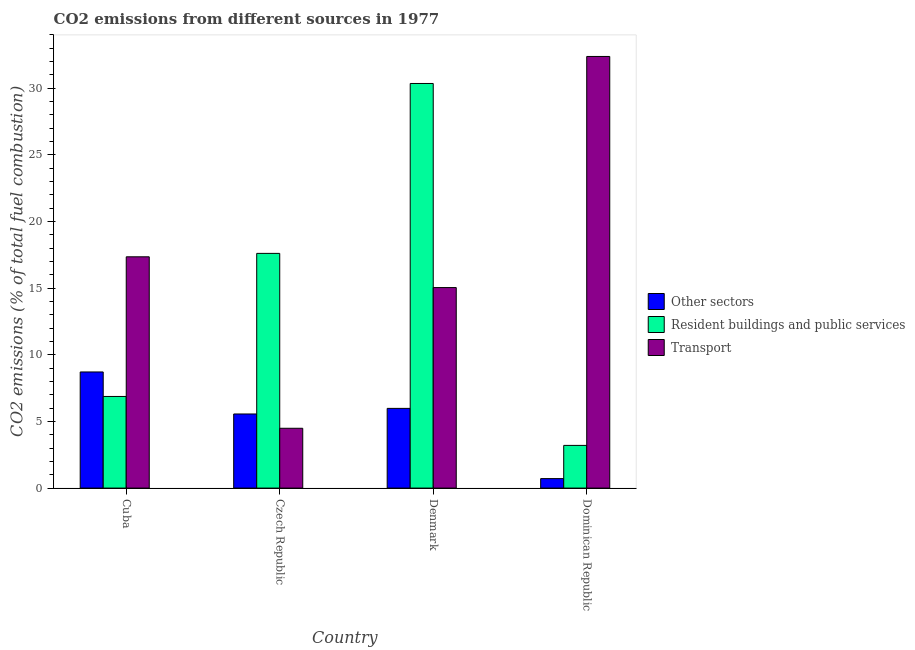How many different coloured bars are there?
Your response must be concise. 3. Are the number of bars per tick equal to the number of legend labels?
Offer a terse response. Yes. Are the number of bars on each tick of the X-axis equal?
Give a very brief answer. Yes. In how many cases, is the number of bars for a given country not equal to the number of legend labels?
Provide a short and direct response. 0. What is the percentage of co2 emissions from other sectors in Cuba?
Keep it short and to the point. 8.71. Across all countries, what is the maximum percentage of co2 emissions from resident buildings and public services?
Your answer should be compact. 30.36. Across all countries, what is the minimum percentage of co2 emissions from resident buildings and public services?
Offer a very short reply. 3.2. In which country was the percentage of co2 emissions from resident buildings and public services minimum?
Offer a very short reply. Dominican Republic. What is the total percentage of co2 emissions from other sectors in the graph?
Your response must be concise. 20.97. What is the difference between the percentage of co2 emissions from other sectors in Czech Republic and that in Dominican Republic?
Provide a succinct answer. 4.85. What is the difference between the percentage of co2 emissions from other sectors in Czech Republic and the percentage of co2 emissions from resident buildings and public services in Dominican Republic?
Offer a terse response. 2.36. What is the average percentage of co2 emissions from resident buildings and public services per country?
Your response must be concise. 14.51. What is the difference between the percentage of co2 emissions from resident buildings and public services and percentage of co2 emissions from transport in Cuba?
Offer a very short reply. -10.48. What is the ratio of the percentage of co2 emissions from transport in Cuba to that in Czech Republic?
Offer a very short reply. 3.87. Is the percentage of co2 emissions from transport in Czech Republic less than that in Dominican Republic?
Provide a succinct answer. Yes. What is the difference between the highest and the second highest percentage of co2 emissions from resident buildings and public services?
Offer a terse response. 12.75. What is the difference between the highest and the lowest percentage of co2 emissions from transport?
Offer a terse response. 27.9. Is the sum of the percentage of co2 emissions from other sectors in Czech Republic and Denmark greater than the maximum percentage of co2 emissions from resident buildings and public services across all countries?
Give a very brief answer. No. What does the 2nd bar from the left in Czech Republic represents?
Make the answer very short. Resident buildings and public services. What does the 3rd bar from the right in Denmark represents?
Give a very brief answer. Other sectors. Are all the bars in the graph horizontal?
Your answer should be very brief. No. Does the graph contain any zero values?
Keep it short and to the point. No. Does the graph contain grids?
Ensure brevity in your answer.  No. Where does the legend appear in the graph?
Your answer should be compact. Center right. How many legend labels are there?
Your response must be concise. 3. How are the legend labels stacked?
Your answer should be compact. Vertical. What is the title of the graph?
Give a very brief answer. CO2 emissions from different sources in 1977. What is the label or title of the X-axis?
Your response must be concise. Country. What is the label or title of the Y-axis?
Offer a terse response. CO2 emissions (% of total fuel combustion). What is the CO2 emissions (% of total fuel combustion) of Other sectors in Cuba?
Offer a very short reply. 8.71. What is the CO2 emissions (% of total fuel combustion) in Resident buildings and public services in Cuba?
Offer a very short reply. 6.88. What is the CO2 emissions (% of total fuel combustion) in Transport in Cuba?
Provide a short and direct response. 17.35. What is the CO2 emissions (% of total fuel combustion) of Other sectors in Czech Republic?
Provide a succinct answer. 5.56. What is the CO2 emissions (% of total fuel combustion) in Resident buildings and public services in Czech Republic?
Your answer should be very brief. 17.61. What is the CO2 emissions (% of total fuel combustion) in Transport in Czech Republic?
Make the answer very short. 4.49. What is the CO2 emissions (% of total fuel combustion) in Other sectors in Denmark?
Give a very brief answer. 5.98. What is the CO2 emissions (% of total fuel combustion) in Resident buildings and public services in Denmark?
Provide a short and direct response. 30.36. What is the CO2 emissions (% of total fuel combustion) in Transport in Denmark?
Ensure brevity in your answer.  15.04. What is the CO2 emissions (% of total fuel combustion) in Other sectors in Dominican Republic?
Offer a terse response. 0.71. What is the CO2 emissions (% of total fuel combustion) in Resident buildings and public services in Dominican Republic?
Provide a short and direct response. 3.2. What is the CO2 emissions (% of total fuel combustion) of Transport in Dominican Republic?
Give a very brief answer. 32.38. Across all countries, what is the maximum CO2 emissions (% of total fuel combustion) in Other sectors?
Provide a short and direct response. 8.71. Across all countries, what is the maximum CO2 emissions (% of total fuel combustion) of Resident buildings and public services?
Give a very brief answer. 30.36. Across all countries, what is the maximum CO2 emissions (% of total fuel combustion) of Transport?
Your response must be concise. 32.38. Across all countries, what is the minimum CO2 emissions (% of total fuel combustion) of Other sectors?
Offer a terse response. 0.71. Across all countries, what is the minimum CO2 emissions (% of total fuel combustion) of Resident buildings and public services?
Offer a terse response. 3.2. Across all countries, what is the minimum CO2 emissions (% of total fuel combustion) in Transport?
Offer a terse response. 4.49. What is the total CO2 emissions (% of total fuel combustion) of Other sectors in the graph?
Make the answer very short. 20.97. What is the total CO2 emissions (% of total fuel combustion) of Resident buildings and public services in the graph?
Offer a very short reply. 58.04. What is the total CO2 emissions (% of total fuel combustion) of Transport in the graph?
Your answer should be very brief. 69.27. What is the difference between the CO2 emissions (% of total fuel combustion) of Other sectors in Cuba and that in Czech Republic?
Make the answer very short. 3.15. What is the difference between the CO2 emissions (% of total fuel combustion) of Resident buildings and public services in Cuba and that in Czech Republic?
Give a very brief answer. -10.73. What is the difference between the CO2 emissions (% of total fuel combustion) of Transport in Cuba and that in Czech Republic?
Make the answer very short. 12.87. What is the difference between the CO2 emissions (% of total fuel combustion) in Other sectors in Cuba and that in Denmark?
Make the answer very short. 2.73. What is the difference between the CO2 emissions (% of total fuel combustion) in Resident buildings and public services in Cuba and that in Denmark?
Your answer should be very brief. -23.48. What is the difference between the CO2 emissions (% of total fuel combustion) in Transport in Cuba and that in Denmark?
Your answer should be very brief. 2.31. What is the difference between the CO2 emissions (% of total fuel combustion) of Other sectors in Cuba and that in Dominican Republic?
Give a very brief answer. 8. What is the difference between the CO2 emissions (% of total fuel combustion) in Resident buildings and public services in Cuba and that in Dominican Republic?
Make the answer very short. 3.67. What is the difference between the CO2 emissions (% of total fuel combustion) in Transport in Cuba and that in Dominican Republic?
Provide a succinct answer. -15.03. What is the difference between the CO2 emissions (% of total fuel combustion) of Other sectors in Czech Republic and that in Denmark?
Give a very brief answer. -0.42. What is the difference between the CO2 emissions (% of total fuel combustion) in Resident buildings and public services in Czech Republic and that in Denmark?
Give a very brief answer. -12.75. What is the difference between the CO2 emissions (% of total fuel combustion) in Transport in Czech Republic and that in Denmark?
Give a very brief answer. -10.56. What is the difference between the CO2 emissions (% of total fuel combustion) in Other sectors in Czech Republic and that in Dominican Republic?
Provide a short and direct response. 4.85. What is the difference between the CO2 emissions (% of total fuel combustion) in Resident buildings and public services in Czech Republic and that in Dominican Republic?
Ensure brevity in your answer.  14.41. What is the difference between the CO2 emissions (% of total fuel combustion) in Transport in Czech Republic and that in Dominican Republic?
Make the answer very short. -27.9. What is the difference between the CO2 emissions (% of total fuel combustion) of Other sectors in Denmark and that in Dominican Republic?
Make the answer very short. 5.27. What is the difference between the CO2 emissions (% of total fuel combustion) of Resident buildings and public services in Denmark and that in Dominican Republic?
Provide a succinct answer. 27.15. What is the difference between the CO2 emissions (% of total fuel combustion) of Transport in Denmark and that in Dominican Republic?
Ensure brevity in your answer.  -17.34. What is the difference between the CO2 emissions (% of total fuel combustion) in Other sectors in Cuba and the CO2 emissions (% of total fuel combustion) in Resident buildings and public services in Czech Republic?
Make the answer very short. -8.9. What is the difference between the CO2 emissions (% of total fuel combustion) in Other sectors in Cuba and the CO2 emissions (% of total fuel combustion) in Transport in Czech Republic?
Provide a short and direct response. 4.23. What is the difference between the CO2 emissions (% of total fuel combustion) in Resident buildings and public services in Cuba and the CO2 emissions (% of total fuel combustion) in Transport in Czech Republic?
Ensure brevity in your answer.  2.39. What is the difference between the CO2 emissions (% of total fuel combustion) of Other sectors in Cuba and the CO2 emissions (% of total fuel combustion) of Resident buildings and public services in Denmark?
Provide a succinct answer. -21.64. What is the difference between the CO2 emissions (% of total fuel combustion) of Other sectors in Cuba and the CO2 emissions (% of total fuel combustion) of Transport in Denmark?
Your answer should be compact. -6.33. What is the difference between the CO2 emissions (% of total fuel combustion) in Resident buildings and public services in Cuba and the CO2 emissions (% of total fuel combustion) in Transport in Denmark?
Give a very brief answer. -8.17. What is the difference between the CO2 emissions (% of total fuel combustion) of Other sectors in Cuba and the CO2 emissions (% of total fuel combustion) of Resident buildings and public services in Dominican Republic?
Make the answer very short. 5.51. What is the difference between the CO2 emissions (% of total fuel combustion) in Other sectors in Cuba and the CO2 emissions (% of total fuel combustion) in Transport in Dominican Republic?
Your answer should be very brief. -23.67. What is the difference between the CO2 emissions (% of total fuel combustion) of Resident buildings and public services in Cuba and the CO2 emissions (% of total fuel combustion) of Transport in Dominican Republic?
Offer a very short reply. -25.51. What is the difference between the CO2 emissions (% of total fuel combustion) in Other sectors in Czech Republic and the CO2 emissions (% of total fuel combustion) in Resident buildings and public services in Denmark?
Your answer should be very brief. -24.8. What is the difference between the CO2 emissions (% of total fuel combustion) in Other sectors in Czech Republic and the CO2 emissions (% of total fuel combustion) in Transport in Denmark?
Your response must be concise. -9.48. What is the difference between the CO2 emissions (% of total fuel combustion) of Resident buildings and public services in Czech Republic and the CO2 emissions (% of total fuel combustion) of Transport in Denmark?
Provide a short and direct response. 2.56. What is the difference between the CO2 emissions (% of total fuel combustion) in Other sectors in Czech Republic and the CO2 emissions (% of total fuel combustion) in Resident buildings and public services in Dominican Republic?
Keep it short and to the point. 2.36. What is the difference between the CO2 emissions (% of total fuel combustion) in Other sectors in Czech Republic and the CO2 emissions (% of total fuel combustion) in Transport in Dominican Republic?
Keep it short and to the point. -26.82. What is the difference between the CO2 emissions (% of total fuel combustion) in Resident buildings and public services in Czech Republic and the CO2 emissions (% of total fuel combustion) in Transport in Dominican Republic?
Ensure brevity in your answer.  -14.78. What is the difference between the CO2 emissions (% of total fuel combustion) of Other sectors in Denmark and the CO2 emissions (% of total fuel combustion) of Resident buildings and public services in Dominican Republic?
Keep it short and to the point. 2.78. What is the difference between the CO2 emissions (% of total fuel combustion) of Other sectors in Denmark and the CO2 emissions (% of total fuel combustion) of Transport in Dominican Republic?
Keep it short and to the point. -26.4. What is the difference between the CO2 emissions (% of total fuel combustion) in Resident buildings and public services in Denmark and the CO2 emissions (% of total fuel combustion) in Transport in Dominican Republic?
Provide a short and direct response. -2.03. What is the average CO2 emissions (% of total fuel combustion) in Other sectors per country?
Your response must be concise. 5.24. What is the average CO2 emissions (% of total fuel combustion) in Resident buildings and public services per country?
Keep it short and to the point. 14.51. What is the average CO2 emissions (% of total fuel combustion) of Transport per country?
Your answer should be very brief. 17.32. What is the difference between the CO2 emissions (% of total fuel combustion) in Other sectors and CO2 emissions (% of total fuel combustion) in Resident buildings and public services in Cuba?
Your answer should be compact. 1.84. What is the difference between the CO2 emissions (% of total fuel combustion) of Other sectors and CO2 emissions (% of total fuel combustion) of Transport in Cuba?
Keep it short and to the point. -8.64. What is the difference between the CO2 emissions (% of total fuel combustion) of Resident buildings and public services and CO2 emissions (% of total fuel combustion) of Transport in Cuba?
Your answer should be compact. -10.48. What is the difference between the CO2 emissions (% of total fuel combustion) in Other sectors and CO2 emissions (% of total fuel combustion) in Resident buildings and public services in Czech Republic?
Your answer should be very brief. -12.05. What is the difference between the CO2 emissions (% of total fuel combustion) in Other sectors and CO2 emissions (% of total fuel combustion) in Transport in Czech Republic?
Provide a short and direct response. 1.07. What is the difference between the CO2 emissions (% of total fuel combustion) in Resident buildings and public services and CO2 emissions (% of total fuel combustion) in Transport in Czech Republic?
Provide a short and direct response. 13.12. What is the difference between the CO2 emissions (% of total fuel combustion) of Other sectors and CO2 emissions (% of total fuel combustion) of Resident buildings and public services in Denmark?
Provide a succinct answer. -24.38. What is the difference between the CO2 emissions (% of total fuel combustion) in Other sectors and CO2 emissions (% of total fuel combustion) in Transport in Denmark?
Provide a succinct answer. -9.06. What is the difference between the CO2 emissions (% of total fuel combustion) of Resident buildings and public services and CO2 emissions (% of total fuel combustion) of Transport in Denmark?
Ensure brevity in your answer.  15.31. What is the difference between the CO2 emissions (% of total fuel combustion) of Other sectors and CO2 emissions (% of total fuel combustion) of Resident buildings and public services in Dominican Republic?
Make the answer very short. -2.49. What is the difference between the CO2 emissions (% of total fuel combustion) of Other sectors and CO2 emissions (% of total fuel combustion) of Transport in Dominican Republic?
Your answer should be very brief. -31.67. What is the difference between the CO2 emissions (% of total fuel combustion) in Resident buildings and public services and CO2 emissions (% of total fuel combustion) in Transport in Dominican Republic?
Make the answer very short. -29.18. What is the ratio of the CO2 emissions (% of total fuel combustion) in Other sectors in Cuba to that in Czech Republic?
Your answer should be very brief. 1.57. What is the ratio of the CO2 emissions (% of total fuel combustion) in Resident buildings and public services in Cuba to that in Czech Republic?
Offer a very short reply. 0.39. What is the ratio of the CO2 emissions (% of total fuel combustion) of Transport in Cuba to that in Czech Republic?
Make the answer very short. 3.87. What is the ratio of the CO2 emissions (% of total fuel combustion) in Other sectors in Cuba to that in Denmark?
Offer a terse response. 1.46. What is the ratio of the CO2 emissions (% of total fuel combustion) in Resident buildings and public services in Cuba to that in Denmark?
Offer a very short reply. 0.23. What is the ratio of the CO2 emissions (% of total fuel combustion) of Transport in Cuba to that in Denmark?
Make the answer very short. 1.15. What is the ratio of the CO2 emissions (% of total fuel combustion) in Other sectors in Cuba to that in Dominican Republic?
Your answer should be compact. 12.24. What is the ratio of the CO2 emissions (% of total fuel combustion) in Resident buildings and public services in Cuba to that in Dominican Republic?
Your answer should be very brief. 2.15. What is the ratio of the CO2 emissions (% of total fuel combustion) of Transport in Cuba to that in Dominican Republic?
Your answer should be very brief. 0.54. What is the ratio of the CO2 emissions (% of total fuel combustion) of Other sectors in Czech Republic to that in Denmark?
Offer a very short reply. 0.93. What is the ratio of the CO2 emissions (% of total fuel combustion) in Resident buildings and public services in Czech Republic to that in Denmark?
Offer a very short reply. 0.58. What is the ratio of the CO2 emissions (% of total fuel combustion) of Transport in Czech Republic to that in Denmark?
Your response must be concise. 0.3. What is the ratio of the CO2 emissions (% of total fuel combustion) of Other sectors in Czech Republic to that in Dominican Republic?
Offer a terse response. 7.81. What is the ratio of the CO2 emissions (% of total fuel combustion) of Resident buildings and public services in Czech Republic to that in Dominican Republic?
Offer a terse response. 5.5. What is the ratio of the CO2 emissions (% of total fuel combustion) of Transport in Czech Republic to that in Dominican Republic?
Your response must be concise. 0.14. What is the ratio of the CO2 emissions (% of total fuel combustion) in Other sectors in Denmark to that in Dominican Republic?
Keep it short and to the point. 8.4. What is the ratio of the CO2 emissions (% of total fuel combustion) in Resident buildings and public services in Denmark to that in Dominican Republic?
Make the answer very short. 9.48. What is the ratio of the CO2 emissions (% of total fuel combustion) of Transport in Denmark to that in Dominican Republic?
Give a very brief answer. 0.46. What is the difference between the highest and the second highest CO2 emissions (% of total fuel combustion) of Other sectors?
Your answer should be very brief. 2.73. What is the difference between the highest and the second highest CO2 emissions (% of total fuel combustion) in Resident buildings and public services?
Give a very brief answer. 12.75. What is the difference between the highest and the second highest CO2 emissions (% of total fuel combustion) in Transport?
Provide a short and direct response. 15.03. What is the difference between the highest and the lowest CO2 emissions (% of total fuel combustion) in Other sectors?
Keep it short and to the point. 8. What is the difference between the highest and the lowest CO2 emissions (% of total fuel combustion) of Resident buildings and public services?
Your answer should be very brief. 27.15. What is the difference between the highest and the lowest CO2 emissions (% of total fuel combustion) of Transport?
Ensure brevity in your answer.  27.9. 